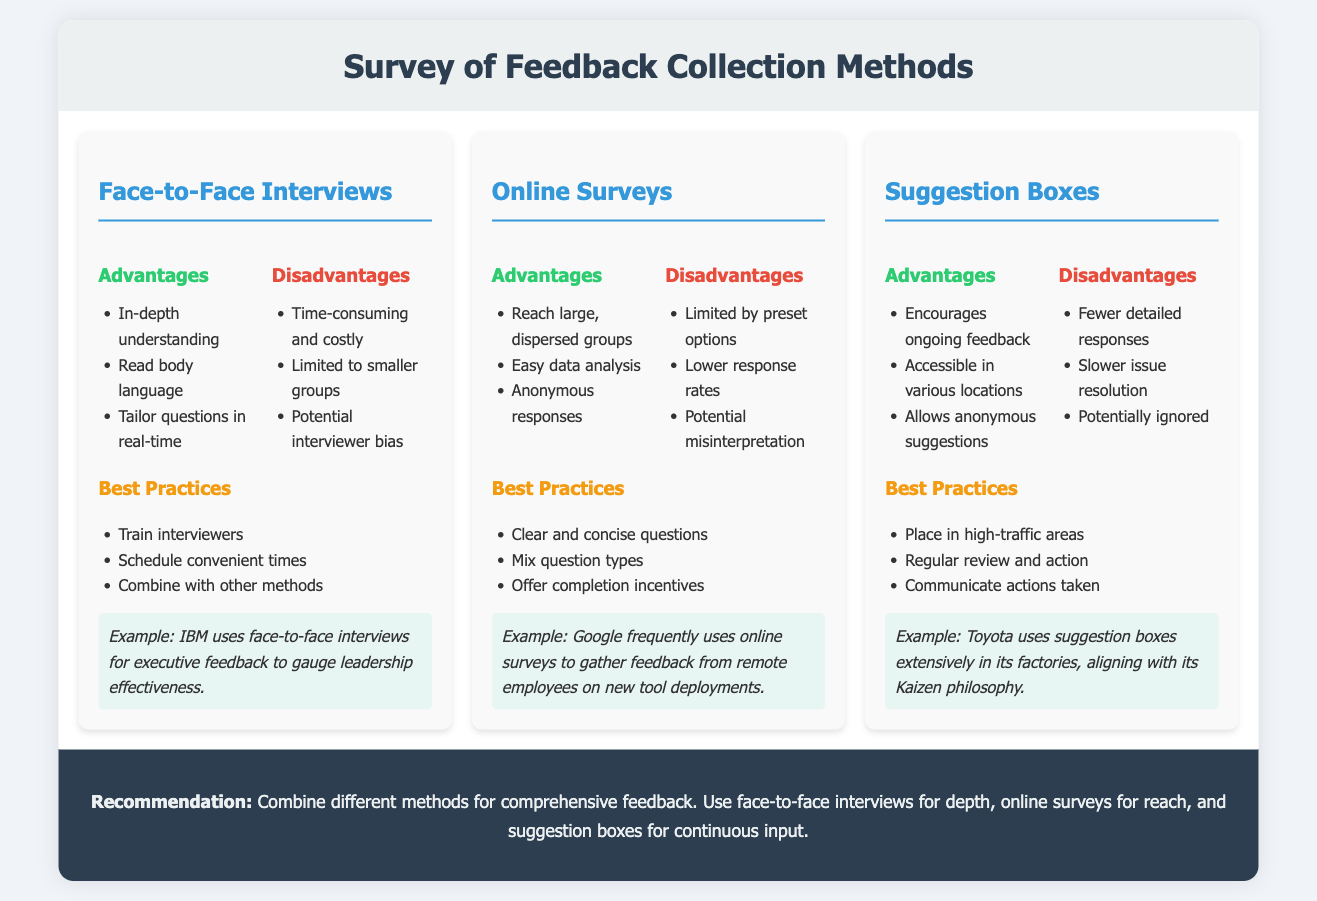what are the three feedback collection methods mentioned? The document outlines three methods: Face-to-Face Interviews, Online Surveys, and Suggestion Boxes.
Answer: Face-to-Face Interviews, Online Surveys, Suggestion Boxes what is one advantage of Face-to-Face Interviews? The document states that one advantage is the ability to gain an in-depth understanding.
Answer: In-depth understanding what is a disadvantage of Suggestion Boxes? According to the document, one disadvantage is that they often lead to fewer detailed responses.
Answer: Fewer detailed responses which company uses online surveys frequently for feedback? The document mentions Google as a company that uses online surveys frequently.
Answer: Google what is a best practice for Online Surveys? One best practice listed is to mix question types to enhance feedback quality.
Answer: Mix question types how can feedback from Face-to-Face Interviews be enhanced? The document suggests enhancing it by training interviewers.
Answer: Train interviewers what is the recommendation for collecting feedback? The recommendation in the document is to combine different methods for comprehensive feedback.
Answer: Combine different methods for comprehensive feedback what action is suggested for Suggestion Boxes to encourage feedback? The document recommends placing suggestion boxes in high-traffic areas.
Answer: Place in high-traffic areas which philosophy does Toyota's use of suggestion boxes align with? The document states that Toyota's use of suggestion boxes aligns with its Kaizen philosophy.
Answer: Kaizen philosophy 